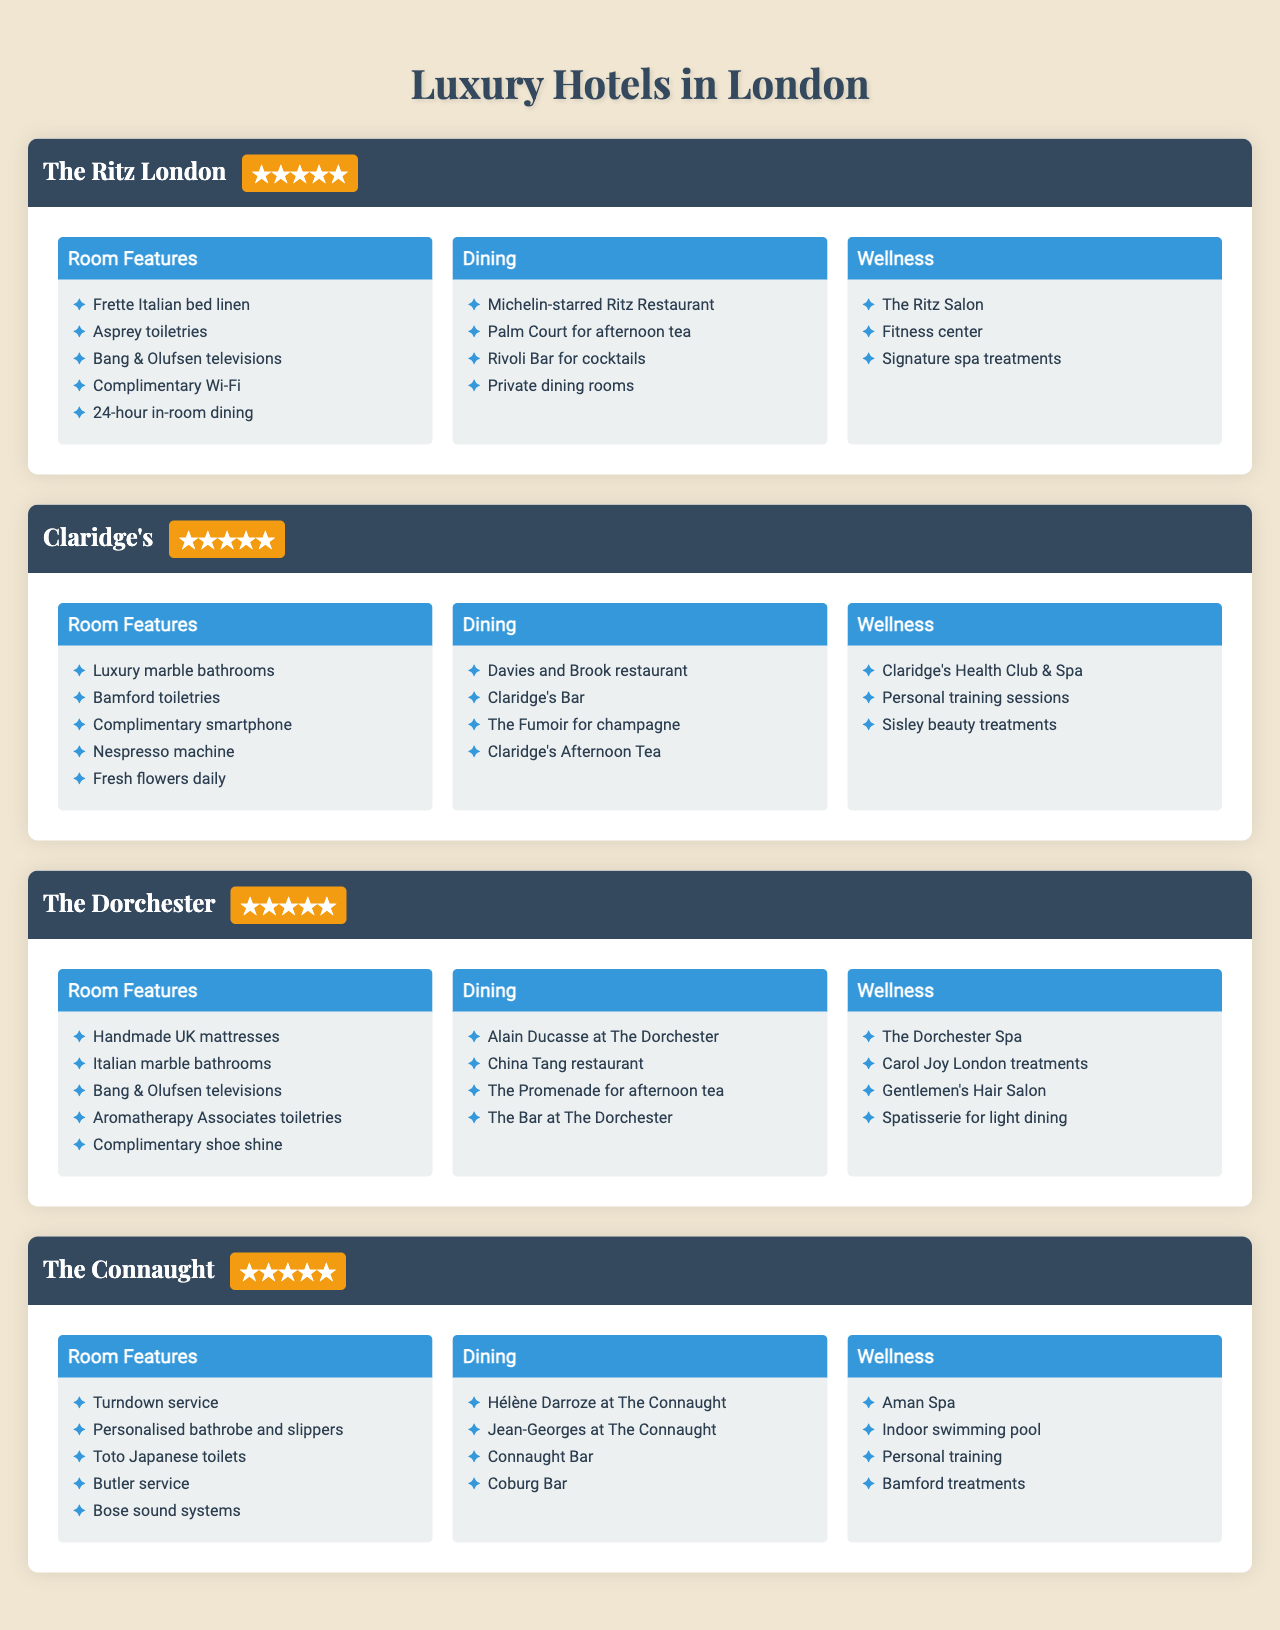What is the star rating of The Ritz London? The Ritz London is listed with a star rating of 5 in the table.
Answer: 5 What amenities are offered in the "Wellness" category at Claridge's? The wellness amenities offered at Claridge's include Claridge's Health Club & Spa, personal training sessions, and Sisley beauty treatments.
Answer: Claridge's Health Club & Spa, personal training sessions, Sisley beauty treatments Does The Dorchester offer Michelin-starred dining? No, The Dorchester does not list any Michelin-starred restaurants; it features Alain Ducasse at The Dorchester, which is a renowned restaurant but not specified as Michelin-starred in the table.
Answer: No Which hotels offer Bang & Olufsen televisions? Both The Ritz London and The Dorchester provide Bang & Olufsen televisions, as stated in their room features.
Answer: The Ritz London and The Dorchester How many guest amenities are listed for The Connaught? The Connaught offers a total of 9 guest amenities, partitioned into 3 categories: Room Features, Dining, and Wellness (5+4+4=13).
Answer: 13 Is there a hotel that provides complimentary Wi-Fi? Yes, The Ritz London provides complimentary Wi-Fi as part of its room features.
Answer: Yes What is the total number of specific dining options listed across all hotels? The Ritz London has 4, Claridge's has 4, The Dorchester has 4, and The Connaught has 4 dining options; summing up gives 4+4+4+4=16.
Answer: 16 Which hotel offers the most variety in wellness amenities? Both The Dorchester and The Connaught offer 4 different wellness amenities each, while The Ritz London offers 3 and Claridge's offers 3, making The Dorchester and The Connaught the leaders in variety.
Answer: The Dorchester and The Connaught What type of toiletries does The Ritz London provide? The Ritz London provides Asprey toiletries as listed under its room features.
Answer: Asprey toiletries Which hotel provides a personal butler service? The Connaught offers a personal butler service as one of its room features.
Answer: The Connaught 